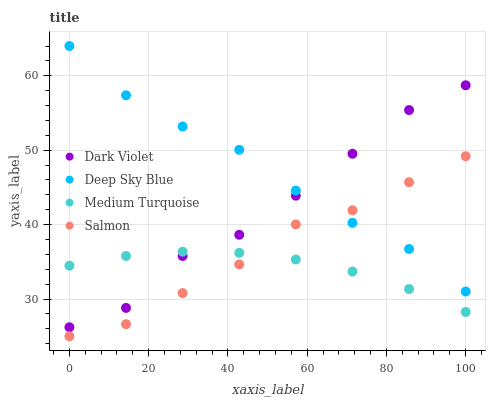Does Medium Turquoise have the minimum area under the curve?
Answer yes or no. Yes. Does Deep Sky Blue have the maximum area under the curve?
Answer yes or no. Yes. Does Salmon have the minimum area under the curve?
Answer yes or no. No. Does Salmon have the maximum area under the curve?
Answer yes or no. No. Is Medium Turquoise the smoothest?
Answer yes or no. Yes. Is Dark Violet the roughest?
Answer yes or no. Yes. Is Salmon the smoothest?
Answer yes or no. No. Is Salmon the roughest?
Answer yes or no. No. Does Salmon have the lowest value?
Answer yes or no. Yes. Does Deep Sky Blue have the lowest value?
Answer yes or no. No. Does Deep Sky Blue have the highest value?
Answer yes or no. Yes. Does Salmon have the highest value?
Answer yes or no. No. Is Salmon less than Dark Violet?
Answer yes or no. Yes. Is Dark Violet greater than Salmon?
Answer yes or no. Yes. Does Salmon intersect Deep Sky Blue?
Answer yes or no. Yes. Is Salmon less than Deep Sky Blue?
Answer yes or no. No. Is Salmon greater than Deep Sky Blue?
Answer yes or no. No. Does Salmon intersect Dark Violet?
Answer yes or no. No. 